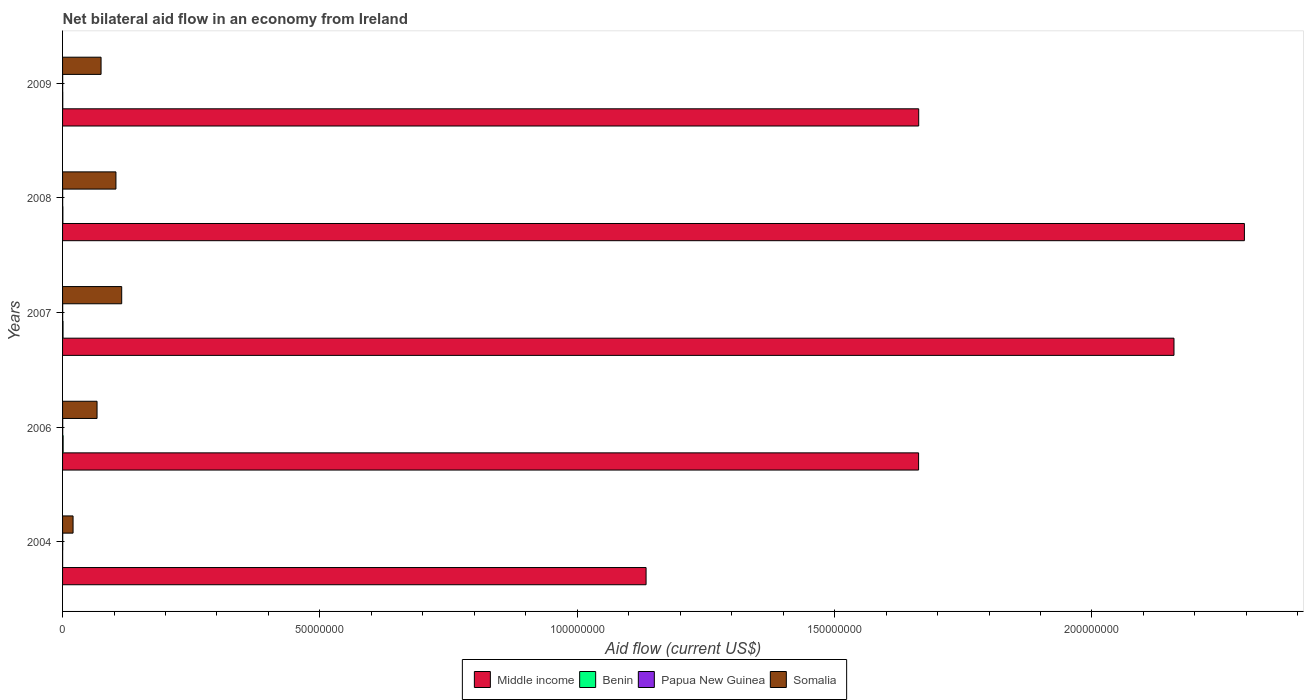How many different coloured bars are there?
Make the answer very short. 4. How many groups of bars are there?
Your answer should be compact. 5. How many bars are there on the 4th tick from the top?
Keep it short and to the point. 4. How many bars are there on the 3rd tick from the bottom?
Ensure brevity in your answer.  4. What is the net bilateral aid flow in Somalia in 2009?
Your answer should be very brief. 7.48e+06. Across all years, what is the minimum net bilateral aid flow in Somalia?
Make the answer very short. 2.04e+06. In which year was the net bilateral aid flow in Middle income maximum?
Ensure brevity in your answer.  2008. In which year was the net bilateral aid flow in Somalia minimum?
Offer a very short reply. 2004. What is the difference between the net bilateral aid flow in Benin in 2006 and that in 2008?
Offer a terse response. 5.00e+04. What is the difference between the net bilateral aid flow in Somalia in 2009 and the net bilateral aid flow in Papua New Guinea in 2008?
Give a very brief answer. 7.46e+06. What is the average net bilateral aid flow in Papua New Guinea per year?
Keep it short and to the point. 2.40e+04. In the year 2008, what is the difference between the net bilateral aid flow in Middle income and net bilateral aid flow in Somalia?
Give a very brief answer. 2.19e+08. Is the net bilateral aid flow in Somalia in 2006 less than that in 2007?
Offer a very short reply. Yes. What is the difference between the highest and the second highest net bilateral aid flow in Papua New Guinea?
Provide a succinct answer. 0. What is the difference between the highest and the lowest net bilateral aid flow in Middle income?
Give a very brief answer. 1.16e+08. What does the 1st bar from the top in 2004 represents?
Your answer should be very brief. Somalia. What does the 2nd bar from the bottom in 2009 represents?
Give a very brief answer. Benin. How many bars are there?
Provide a succinct answer. 20. What is the difference between two consecutive major ticks on the X-axis?
Ensure brevity in your answer.  5.00e+07. Does the graph contain grids?
Your response must be concise. No. How many legend labels are there?
Keep it short and to the point. 4. What is the title of the graph?
Keep it short and to the point. Net bilateral aid flow in an economy from Ireland. What is the Aid flow (current US$) of Middle income in 2004?
Give a very brief answer. 1.13e+08. What is the Aid flow (current US$) of Benin in 2004?
Your response must be concise. 10000. What is the Aid flow (current US$) in Papua New Guinea in 2004?
Ensure brevity in your answer.  3.00e+04. What is the Aid flow (current US$) of Somalia in 2004?
Ensure brevity in your answer.  2.04e+06. What is the Aid flow (current US$) of Middle income in 2006?
Offer a very short reply. 1.66e+08. What is the Aid flow (current US$) of Somalia in 2006?
Your answer should be very brief. 6.70e+06. What is the Aid flow (current US$) in Middle income in 2007?
Your answer should be compact. 2.16e+08. What is the Aid flow (current US$) of Somalia in 2007?
Offer a terse response. 1.15e+07. What is the Aid flow (current US$) in Middle income in 2008?
Your response must be concise. 2.30e+08. What is the Aid flow (current US$) in Benin in 2008?
Give a very brief answer. 6.00e+04. What is the Aid flow (current US$) of Papua New Guinea in 2008?
Offer a very short reply. 2.00e+04. What is the Aid flow (current US$) in Somalia in 2008?
Offer a very short reply. 1.04e+07. What is the Aid flow (current US$) of Middle income in 2009?
Offer a terse response. 1.66e+08. What is the Aid flow (current US$) in Benin in 2009?
Provide a succinct answer. 4.00e+04. What is the Aid flow (current US$) in Somalia in 2009?
Offer a terse response. 7.48e+06. Across all years, what is the maximum Aid flow (current US$) in Middle income?
Provide a short and direct response. 2.30e+08. Across all years, what is the maximum Aid flow (current US$) in Papua New Guinea?
Offer a very short reply. 3.00e+04. Across all years, what is the maximum Aid flow (current US$) of Somalia?
Offer a very short reply. 1.15e+07. Across all years, what is the minimum Aid flow (current US$) of Middle income?
Ensure brevity in your answer.  1.13e+08. Across all years, what is the minimum Aid flow (current US$) in Benin?
Provide a short and direct response. 10000. Across all years, what is the minimum Aid flow (current US$) in Papua New Guinea?
Give a very brief answer. 2.00e+04. Across all years, what is the minimum Aid flow (current US$) of Somalia?
Ensure brevity in your answer.  2.04e+06. What is the total Aid flow (current US$) in Middle income in the graph?
Ensure brevity in your answer.  8.92e+08. What is the total Aid flow (current US$) of Benin in the graph?
Your answer should be very brief. 3.10e+05. What is the total Aid flow (current US$) of Somalia in the graph?
Keep it short and to the point. 3.81e+07. What is the difference between the Aid flow (current US$) in Middle income in 2004 and that in 2006?
Give a very brief answer. -5.30e+07. What is the difference between the Aid flow (current US$) of Papua New Guinea in 2004 and that in 2006?
Your response must be concise. 0. What is the difference between the Aid flow (current US$) in Somalia in 2004 and that in 2006?
Offer a terse response. -4.66e+06. What is the difference between the Aid flow (current US$) in Middle income in 2004 and that in 2007?
Your answer should be very brief. -1.03e+08. What is the difference between the Aid flow (current US$) of Papua New Guinea in 2004 and that in 2007?
Ensure brevity in your answer.  10000. What is the difference between the Aid flow (current US$) in Somalia in 2004 and that in 2007?
Your answer should be very brief. -9.45e+06. What is the difference between the Aid flow (current US$) in Middle income in 2004 and that in 2008?
Your answer should be very brief. -1.16e+08. What is the difference between the Aid flow (current US$) in Benin in 2004 and that in 2008?
Give a very brief answer. -5.00e+04. What is the difference between the Aid flow (current US$) of Somalia in 2004 and that in 2008?
Give a very brief answer. -8.33e+06. What is the difference between the Aid flow (current US$) in Middle income in 2004 and that in 2009?
Your answer should be compact. -5.30e+07. What is the difference between the Aid flow (current US$) in Benin in 2004 and that in 2009?
Provide a succinct answer. -3.00e+04. What is the difference between the Aid flow (current US$) of Papua New Guinea in 2004 and that in 2009?
Offer a terse response. 10000. What is the difference between the Aid flow (current US$) of Somalia in 2004 and that in 2009?
Your response must be concise. -5.44e+06. What is the difference between the Aid flow (current US$) in Middle income in 2006 and that in 2007?
Provide a succinct answer. -4.96e+07. What is the difference between the Aid flow (current US$) of Somalia in 2006 and that in 2007?
Provide a succinct answer. -4.79e+06. What is the difference between the Aid flow (current US$) in Middle income in 2006 and that in 2008?
Ensure brevity in your answer.  -6.33e+07. What is the difference between the Aid flow (current US$) in Somalia in 2006 and that in 2008?
Offer a terse response. -3.67e+06. What is the difference between the Aid flow (current US$) of Middle income in 2006 and that in 2009?
Make the answer very short. -2.00e+04. What is the difference between the Aid flow (current US$) of Benin in 2006 and that in 2009?
Give a very brief answer. 7.00e+04. What is the difference between the Aid flow (current US$) in Papua New Guinea in 2006 and that in 2009?
Provide a succinct answer. 10000. What is the difference between the Aid flow (current US$) of Somalia in 2006 and that in 2009?
Offer a terse response. -7.80e+05. What is the difference between the Aid flow (current US$) in Middle income in 2007 and that in 2008?
Offer a terse response. -1.37e+07. What is the difference between the Aid flow (current US$) of Benin in 2007 and that in 2008?
Your answer should be very brief. 3.00e+04. What is the difference between the Aid flow (current US$) of Somalia in 2007 and that in 2008?
Keep it short and to the point. 1.12e+06. What is the difference between the Aid flow (current US$) in Middle income in 2007 and that in 2009?
Make the answer very short. 4.96e+07. What is the difference between the Aid flow (current US$) of Somalia in 2007 and that in 2009?
Provide a succinct answer. 4.01e+06. What is the difference between the Aid flow (current US$) of Middle income in 2008 and that in 2009?
Provide a short and direct response. 6.33e+07. What is the difference between the Aid flow (current US$) of Somalia in 2008 and that in 2009?
Make the answer very short. 2.89e+06. What is the difference between the Aid flow (current US$) in Middle income in 2004 and the Aid flow (current US$) in Benin in 2006?
Offer a terse response. 1.13e+08. What is the difference between the Aid flow (current US$) in Middle income in 2004 and the Aid flow (current US$) in Papua New Guinea in 2006?
Your response must be concise. 1.13e+08. What is the difference between the Aid flow (current US$) of Middle income in 2004 and the Aid flow (current US$) of Somalia in 2006?
Give a very brief answer. 1.07e+08. What is the difference between the Aid flow (current US$) in Benin in 2004 and the Aid flow (current US$) in Somalia in 2006?
Offer a terse response. -6.69e+06. What is the difference between the Aid flow (current US$) of Papua New Guinea in 2004 and the Aid flow (current US$) of Somalia in 2006?
Provide a short and direct response. -6.67e+06. What is the difference between the Aid flow (current US$) in Middle income in 2004 and the Aid flow (current US$) in Benin in 2007?
Provide a succinct answer. 1.13e+08. What is the difference between the Aid flow (current US$) of Middle income in 2004 and the Aid flow (current US$) of Papua New Guinea in 2007?
Your response must be concise. 1.13e+08. What is the difference between the Aid flow (current US$) of Middle income in 2004 and the Aid flow (current US$) of Somalia in 2007?
Provide a short and direct response. 1.02e+08. What is the difference between the Aid flow (current US$) of Benin in 2004 and the Aid flow (current US$) of Papua New Guinea in 2007?
Ensure brevity in your answer.  -10000. What is the difference between the Aid flow (current US$) in Benin in 2004 and the Aid flow (current US$) in Somalia in 2007?
Make the answer very short. -1.15e+07. What is the difference between the Aid flow (current US$) in Papua New Guinea in 2004 and the Aid flow (current US$) in Somalia in 2007?
Ensure brevity in your answer.  -1.15e+07. What is the difference between the Aid flow (current US$) in Middle income in 2004 and the Aid flow (current US$) in Benin in 2008?
Your answer should be very brief. 1.13e+08. What is the difference between the Aid flow (current US$) of Middle income in 2004 and the Aid flow (current US$) of Papua New Guinea in 2008?
Your response must be concise. 1.13e+08. What is the difference between the Aid flow (current US$) in Middle income in 2004 and the Aid flow (current US$) in Somalia in 2008?
Provide a short and direct response. 1.03e+08. What is the difference between the Aid flow (current US$) of Benin in 2004 and the Aid flow (current US$) of Papua New Guinea in 2008?
Your answer should be very brief. -10000. What is the difference between the Aid flow (current US$) of Benin in 2004 and the Aid flow (current US$) of Somalia in 2008?
Your answer should be very brief. -1.04e+07. What is the difference between the Aid flow (current US$) in Papua New Guinea in 2004 and the Aid flow (current US$) in Somalia in 2008?
Ensure brevity in your answer.  -1.03e+07. What is the difference between the Aid flow (current US$) in Middle income in 2004 and the Aid flow (current US$) in Benin in 2009?
Provide a short and direct response. 1.13e+08. What is the difference between the Aid flow (current US$) of Middle income in 2004 and the Aid flow (current US$) of Papua New Guinea in 2009?
Make the answer very short. 1.13e+08. What is the difference between the Aid flow (current US$) in Middle income in 2004 and the Aid flow (current US$) in Somalia in 2009?
Make the answer very short. 1.06e+08. What is the difference between the Aid flow (current US$) in Benin in 2004 and the Aid flow (current US$) in Somalia in 2009?
Provide a short and direct response. -7.47e+06. What is the difference between the Aid flow (current US$) of Papua New Guinea in 2004 and the Aid flow (current US$) of Somalia in 2009?
Keep it short and to the point. -7.45e+06. What is the difference between the Aid flow (current US$) of Middle income in 2006 and the Aid flow (current US$) of Benin in 2007?
Ensure brevity in your answer.  1.66e+08. What is the difference between the Aid flow (current US$) of Middle income in 2006 and the Aid flow (current US$) of Papua New Guinea in 2007?
Your response must be concise. 1.66e+08. What is the difference between the Aid flow (current US$) in Middle income in 2006 and the Aid flow (current US$) in Somalia in 2007?
Keep it short and to the point. 1.55e+08. What is the difference between the Aid flow (current US$) of Benin in 2006 and the Aid flow (current US$) of Papua New Guinea in 2007?
Provide a short and direct response. 9.00e+04. What is the difference between the Aid flow (current US$) of Benin in 2006 and the Aid flow (current US$) of Somalia in 2007?
Your response must be concise. -1.14e+07. What is the difference between the Aid flow (current US$) of Papua New Guinea in 2006 and the Aid flow (current US$) of Somalia in 2007?
Offer a very short reply. -1.15e+07. What is the difference between the Aid flow (current US$) of Middle income in 2006 and the Aid flow (current US$) of Benin in 2008?
Keep it short and to the point. 1.66e+08. What is the difference between the Aid flow (current US$) in Middle income in 2006 and the Aid flow (current US$) in Papua New Guinea in 2008?
Your answer should be very brief. 1.66e+08. What is the difference between the Aid flow (current US$) in Middle income in 2006 and the Aid flow (current US$) in Somalia in 2008?
Offer a very short reply. 1.56e+08. What is the difference between the Aid flow (current US$) of Benin in 2006 and the Aid flow (current US$) of Papua New Guinea in 2008?
Offer a terse response. 9.00e+04. What is the difference between the Aid flow (current US$) of Benin in 2006 and the Aid flow (current US$) of Somalia in 2008?
Offer a very short reply. -1.03e+07. What is the difference between the Aid flow (current US$) of Papua New Guinea in 2006 and the Aid flow (current US$) of Somalia in 2008?
Offer a terse response. -1.03e+07. What is the difference between the Aid flow (current US$) of Middle income in 2006 and the Aid flow (current US$) of Benin in 2009?
Your answer should be very brief. 1.66e+08. What is the difference between the Aid flow (current US$) in Middle income in 2006 and the Aid flow (current US$) in Papua New Guinea in 2009?
Your answer should be very brief. 1.66e+08. What is the difference between the Aid flow (current US$) in Middle income in 2006 and the Aid flow (current US$) in Somalia in 2009?
Offer a very short reply. 1.59e+08. What is the difference between the Aid flow (current US$) in Benin in 2006 and the Aid flow (current US$) in Somalia in 2009?
Provide a succinct answer. -7.37e+06. What is the difference between the Aid flow (current US$) of Papua New Guinea in 2006 and the Aid flow (current US$) of Somalia in 2009?
Ensure brevity in your answer.  -7.45e+06. What is the difference between the Aid flow (current US$) in Middle income in 2007 and the Aid flow (current US$) in Benin in 2008?
Your response must be concise. 2.16e+08. What is the difference between the Aid flow (current US$) in Middle income in 2007 and the Aid flow (current US$) in Papua New Guinea in 2008?
Offer a very short reply. 2.16e+08. What is the difference between the Aid flow (current US$) of Middle income in 2007 and the Aid flow (current US$) of Somalia in 2008?
Offer a very short reply. 2.06e+08. What is the difference between the Aid flow (current US$) in Benin in 2007 and the Aid flow (current US$) in Somalia in 2008?
Provide a short and direct response. -1.03e+07. What is the difference between the Aid flow (current US$) in Papua New Guinea in 2007 and the Aid flow (current US$) in Somalia in 2008?
Make the answer very short. -1.04e+07. What is the difference between the Aid flow (current US$) of Middle income in 2007 and the Aid flow (current US$) of Benin in 2009?
Ensure brevity in your answer.  2.16e+08. What is the difference between the Aid flow (current US$) in Middle income in 2007 and the Aid flow (current US$) in Papua New Guinea in 2009?
Offer a terse response. 2.16e+08. What is the difference between the Aid flow (current US$) in Middle income in 2007 and the Aid flow (current US$) in Somalia in 2009?
Offer a terse response. 2.08e+08. What is the difference between the Aid flow (current US$) of Benin in 2007 and the Aid flow (current US$) of Papua New Guinea in 2009?
Your response must be concise. 7.00e+04. What is the difference between the Aid flow (current US$) of Benin in 2007 and the Aid flow (current US$) of Somalia in 2009?
Your response must be concise. -7.39e+06. What is the difference between the Aid flow (current US$) of Papua New Guinea in 2007 and the Aid flow (current US$) of Somalia in 2009?
Give a very brief answer. -7.46e+06. What is the difference between the Aid flow (current US$) of Middle income in 2008 and the Aid flow (current US$) of Benin in 2009?
Ensure brevity in your answer.  2.30e+08. What is the difference between the Aid flow (current US$) in Middle income in 2008 and the Aid flow (current US$) in Papua New Guinea in 2009?
Provide a short and direct response. 2.30e+08. What is the difference between the Aid flow (current US$) of Middle income in 2008 and the Aid flow (current US$) of Somalia in 2009?
Provide a succinct answer. 2.22e+08. What is the difference between the Aid flow (current US$) of Benin in 2008 and the Aid flow (current US$) of Papua New Guinea in 2009?
Offer a terse response. 4.00e+04. What is the difference between the Aid flow (current US$) of Benin in 2008 and the Aid flow (current US$) of Somalia in 2009?
Provide a short and direct response. -7.42e+06. What is the difference between the Aid flow (current US$) in Papua New Guinea in 2008 and the Aid flow (current US$) in Somalia in 2009?
Ensure brevity in your answer.  -7.46e+06. What is the average Aid flow (current US$) of Middle income per year?
Keep it short and to the point. 1.78e+08. What is the average Aid flow (current US$) in Benin per year?
Provide a short and direct response. 6.20e+04. What is the average Aid flow (current US$) of Papua New Guinea per year?
Make the answer very short. 2.40e+04. What is the average Aid flow (current US$) in Somalia per year?
Provide a short and direct response. 7.62e+06. In the year 2004, what is the difference between the Aid flow (current US$) in Middle income and Aid flow (current US$) in Benin?
Offer a very short reply. 1.13e+08. In the year 2004, what is the difference between the Aid flow (current US$) in Middle income and Aid flow (current US$) in Papua New Guinea?
Your answer should be very brief. 1.13e+08. In the year 2004, what is the difference between the Aid flow (current US$) in Middle income and Aid flow (current US$) in Somalia?
Provide a succinct answer. 1.11e+08. In the year 2004, what is the difference between the Aid flow (current US$) of Benin and Aid flow (current US$) of Papua New Guinea?
Make the answer very short. -2.00e+04. In the year 2004, what is the difference between the Aid flow (current US$) of Benin and Aid flow (current US$) of Somalia?
Offer a very short reply. -2.03e+06. In the year 2004, what is the difference between the Aid flow (current US$) of Papua New Guinea and Aid flow (current US$) of Somalia?
Your answer should be compact. -2.01e+06. In the year 2006, what is the difference between the Aid flow (current US$) of Middle income and Aid flow (current US$) of Benin?
Offer a terse response. 1.66e+08. In the year 2006, what is the difference between the Aid flow (current US$) of Middle income and Aid flow (current US$) of Papua New Guinea?
Offer a very short reply. 1.66e+08. In the year 2006, what is the difference between the Aid flow (current US$) of Middle income and Aid flow (current US$) of Somalia?
Offer a very short reply. 1.60e+08. In the year 2006, what is the difference between the Aid flow (current US$) in Benin and Aid flow (current US$) in Papua New Guinea?
Provide a short and direct response. 8.00e+04. In the year 2006, what is the difference between the Aid flow (current US$) in Benin and Aid flow (current US$) in Somalia?
Ensure brevity in your answer.  -6.59e+06. In the year 2006, what is the difference between the Aid flow (current US$) of Papua New Guinea and Aid flow (current US$) of Somalia?
Offer a very short reply. -6.67e+06. In the year 2007, what is the difference between the Aid flow (current US$) in Middle income and Aid flow (current US$) in Benin?
Offer a terse response. 2.16e+08. In the year 2007, what is the difference between the Aid flow (current US$) in Middle income and Aid flow (current US$) in Papua New Guinea?
Make the answer very short. 2.16e+08. In the year 2007, what is the difference between the Aid flow (current US$) in Middle income and Aid flow (current US$) in Somalia?
Provide a short and direct response. 2.04e+08. In the year 2007, what is the difference between the Aid flow (current US$) in Benin and Aid flow (current US$) in Somalia?
Offer a terse response. -1.14e+07. In the year 2007, what is the difference between the Aid flow (current US$) of Papua New Guinea and Aid flow (current US$) of Somalia?
Offer a very short reply. -1.15e+07. In the year 2008, what is the difference between the Aid flow (current US$) of Middle income and Aid flow (current US$) of Benin?
Your response must be concise. 2.30e+08. In the year 2008, what is the difference between the Aid flow (current US$) in Middle income and Aid flow (current US$) in Papua New Guinea?
Offer a very short reply. 2.30e+08. In the year 2008, what is the difference between the Aid flow (current US$) of Middle income and Aid flow (current US$) of Somalia?
Give a very brief answer. 2.19e+08. In the year 2008, what is the difference between the Aid flow (current US$) in Benin and Aid flow (current US$) in Somalia?
Provide a succinct answer. -1.03e+07. In the year 2008, what is the difference between the Aid flow (current US$) of Papua New Guinea and Aid flow (current US$) of Somalia?
Provide a succinct answer. -1.04e+07. In the year 2009, what is the difference between the Aid flow (current US$) in Middle income and Aid flow (current US$) in Benin?
Make the answer very short. 1.66e+08. In the year 2009, what is the difference between the Aid flow (current US$) of Middle income and Aid flow (current US$) of Papua New Guinea?
Ensure brevity in your answer.  1.66e+08. In the year 2009, what is the difference between the Aid flow (current US$) of Middle income and Aid flow (current US$) of Somalia?
Your answer should be compact. 1.59e+08. In the year 2009, what is the difference between the Aid flow (current US$) of Benin and Aid flow (current US$) of Somalia?
Give a very brief answer. -7.44e+06. In the year 2009, what is the difference between the Aid flow (current US$) of Papua New Guinea and Aid flow (current US$) of Somalia?
Keep it short and to the point. -7.46e+06. What is the ratio of the Aid flow (current US$) of Middle income in 2004 to that in 2006?
Make the answer very short. 0.68. What is the ratio of the Aid flow (current US$) of Benin in 2004 to that in 2006?
Make the answer very short. 0.09. What is the ratio of the Aid flow (current US$) in Somalia in 2004 to that in 2006?
Your answer should be very brief. 0.3. What is the ratio of the Aid flow (current US$) of Middle income in 2004 to that in 2007?
Make the answer very short. 0.53. What is the ratio of the Aid flow (current US$) in Papua New Guinea in 2004 to that in 2007?
Keep it short and to the point. 1.5. What is the ratio of the Aid flow (current US$) in Somalia in 2004 to that in 2007?
Offer a very short reply. 0.18. What is the ratio of the Aid flow (current US$) in Middle income in 2004 to that in 2008?
Offer a terse response. 0.49. What is the ratio of the Aid flow (current US$) in Benin in 2004 to that in 2008?
Your answer should be very brief. 0.17. What is the ratio of the Aid flow (current US$) in Somalia in 2004 to that in 2008?
Make the answer very short. 0.2. What is the ratio of the Aid flow (current US$) of Middle income in 2004 to that in 2009?
Ensure brevity in your answer.  0.68. What is the ratio of the Aid flow (current US$) of Benin in 2004 to that in 2009?
Your answer should be compact. 0.25. What is the ratio of the Aid flow (current US$) of Papua New Guinea in 2004 to that in 2009?
Give a very brief answer. 1.5. What is the ratio of the Aid flow (current US$) in Somalia in 2004 to that in 2009?
Your answer should be very brief. 0.27. What is the ratio of the Aid flow (current US$) of Middle income in 2006 to that in 2007?
Your answer should be very brief. 0.77. What is the ratio of the Aid flow (current US$) of Benin in 2006 to that in 2007?
Offer a very short reply. 1.22. What is the ratio of the Aid flow (current US$) in Somalia in 2006 to that in 2007?
Offer a very short reply. 0.58. What is the ratio of the Aid flow (current US$) of Middle income in 2006 to that in 2008?
Your response must be concise. 0.72. What is the ratio of the Aid flow (current US$) of Benin in 2006 to that in 2008?
Your response must be concise. 1.83. What is the ratio of the Aid flow (current US$) in Somalia in 2006 to that in 2008?
Your response must be concise. 0.65. What is the ratio of the Aid flow (current US$) of Benin in 2006 to that in 2009?
Provide a short and direct response. 2.75. What is the ratio of the Aid flow (current US$) of Somalia in 2006 to that in 2009?
Your answer should be very brief. 0.9. What is the ratio of the Aid flow (current US$) in Middle income in 2007 to that in 2008?
Offer a very short reply. 0.94. What is the ratio of the Aid flow (current US$) of Benin in 2007 to that in 2008?
Make the answer very short. 1.5. What is the ratio of the Aid flow (current US$) in Papua New Guinea in 2007 to that in 2008?
Offer a terse response. 1. What is the ratio of the Aid flow (current US$) of Somalia in 2007 to that in 2008?
Your answer should be compact. 1.11. What is the ratio of the Aid flow (current US$) in Middle income in 2007 to that in 2009?
Provide a short and direct response. 1.3. What is the ratio of the Aid flow (current US$) of Benin in 2007 to that in 2009?
Offer a very short reply. 2.25. What is the ratio of the Aid flow (current US$) of Somalia in 2007 to that in 2009?
Give a very brief answer. 1.54. What is the ratio of the Aid flow (current US$) in Middle income in 2008 to that in 2009?
Provide a short and direct response. 1.38. What is the ratio of the Aid flow (current US$) of Somalia in 2008 to that in 2009?
Make the answer very short. 1.39. What is the difference between the highest and the second highest Aid flow (current US$) in Middle income?
Provide a short and direct response. 1.37e+07. What is the difference between the highest and the second highest Aid flow (current US$) in Benin?
Make the answer very short. 2.00e+04. What is the difference between the highest and the second highest Aid flow (current US$) in Somalia?
Your answer should be very brief. 1.12e+06. What is the difference between the highest and the lowest Aid flow (current US$) of Middle income?
Your answer should be very brief. 1.16e+08. What is the difference between the highest and the lowest Aid flow (current US$) of Benin?
Give a very brief answer. 1.00e+05. What is the difference between the highest and the lowest Aid flow (current US$) of Somalia?
Offer a terse response. 9.45e+06. 